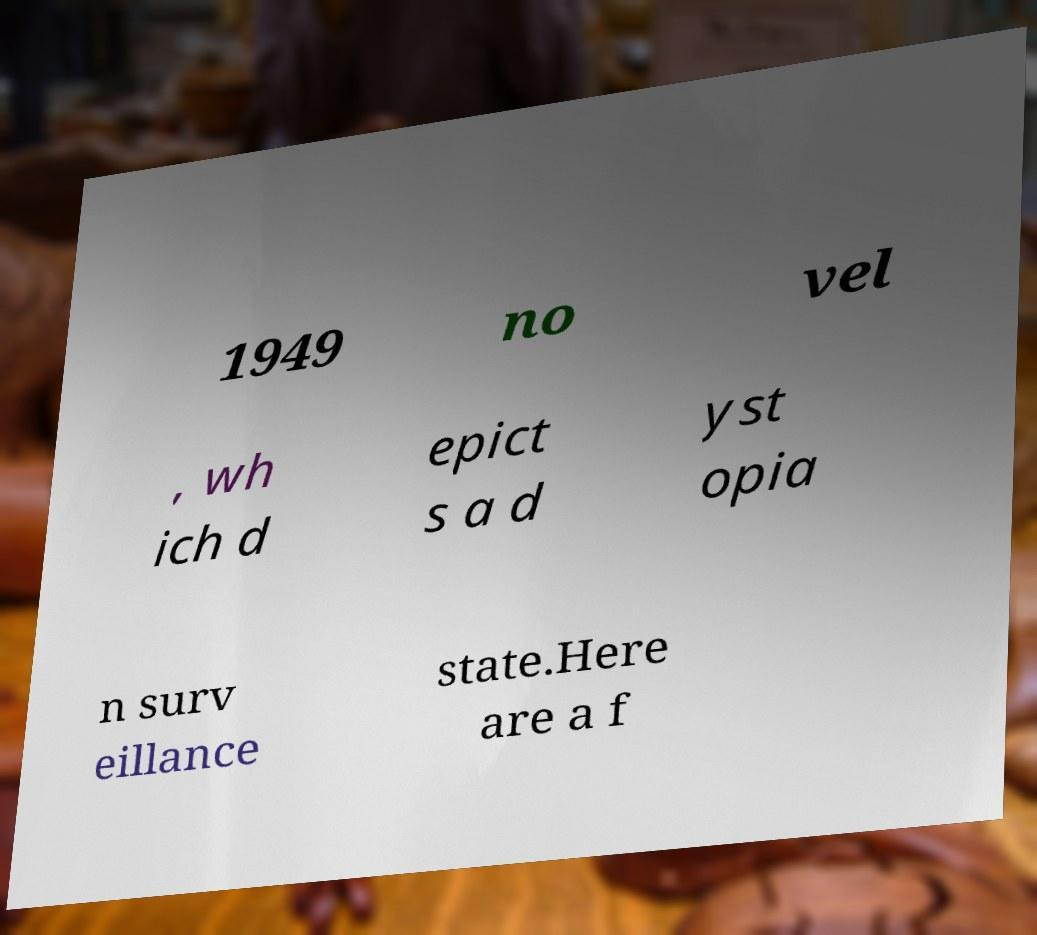Please read and relay the text visible in this image. What does it say? 1949 no vel , wh ich d epict s a d yst opia n surv eillance state.Here are a f 